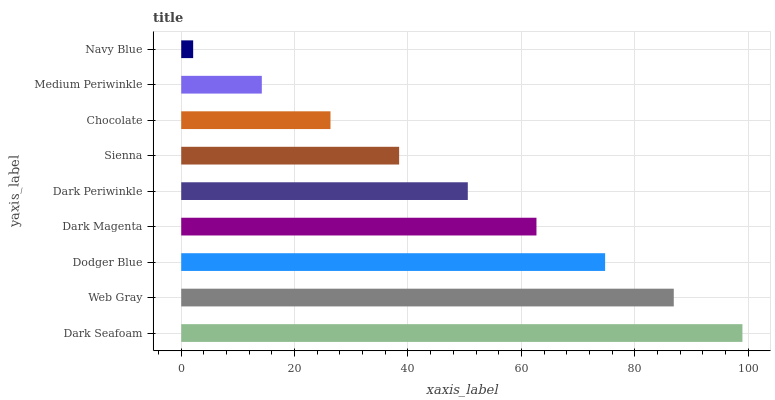Is Navy Blue the minimum?
Answer yes or no. Yes. Is Dark Seafoam the maximum?
Answer yes or no. Yes. Is Web Gray the minimum?
Answer yes or no. No. Is Web Gray the maximum?
Answer yes or no. No. Is Dark Seafoam greater than Web Gray?
Answer yes or no. Yes. Is Web Gray less than Dark Seafoam?
Answer yes or no. Yes. Is Web Gray greater than Dark Seafoam?
Answer yes or no. No. Is Dark Seafoam less than Web Gray?
Answer yes or no. No. Is Dark Periwinkle the high median?
Answer yes or no. Yes. Is Dark Periwinkle the low median?
Answer yes or no. Yes. Is Dodger Blue the high median?
Answer yes or no. No. Is Dark Magenta the low median?
Answer yes or no. No. 